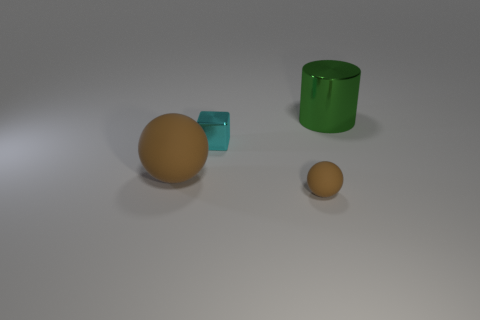What size is the other rubber object that is the same shape as the tiny brown thing?
Provide a succinct answer. Large. Is the number of matte balls that are behind the green shiny cylinder the same as the number of green things that are on the left side of the cube?
Provide a short and direct response. Yes. How many metal objects are there?
Your response must be concise. 2. Is the number of brown matte balls behind the big metallic thing greater than the number of cyan shiny blocks?
Make the answer very short. No. What is the material of the large thing on the right side of the small cyan shiny object?
Provide a succinct answer. Metal. What is the color of the small object that is the same shape as the big brown thing?
Your answer should be compact. Brown. What number of small cubes have the same color as the small metal thing?
Provide a short and direct response. 0. Does the metal thing in front of the green thing have the same size as the rubber ball that is to the right of the small cyan block?
Give a very brief answer. Yes. There is a cyan metallic cube; does it have the same size as the brown sphere that is in front of the big brown object?
Your answer should be compact. Yes. What is the size of the metallic block?
Keep it short and to the point. Small. 